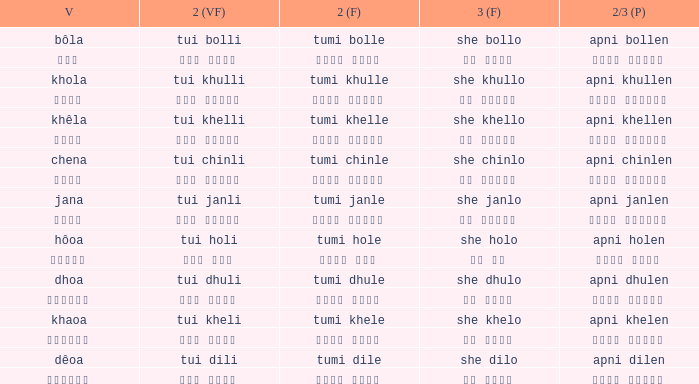What is the verb for তুমি খেলে? খাওয়া. 